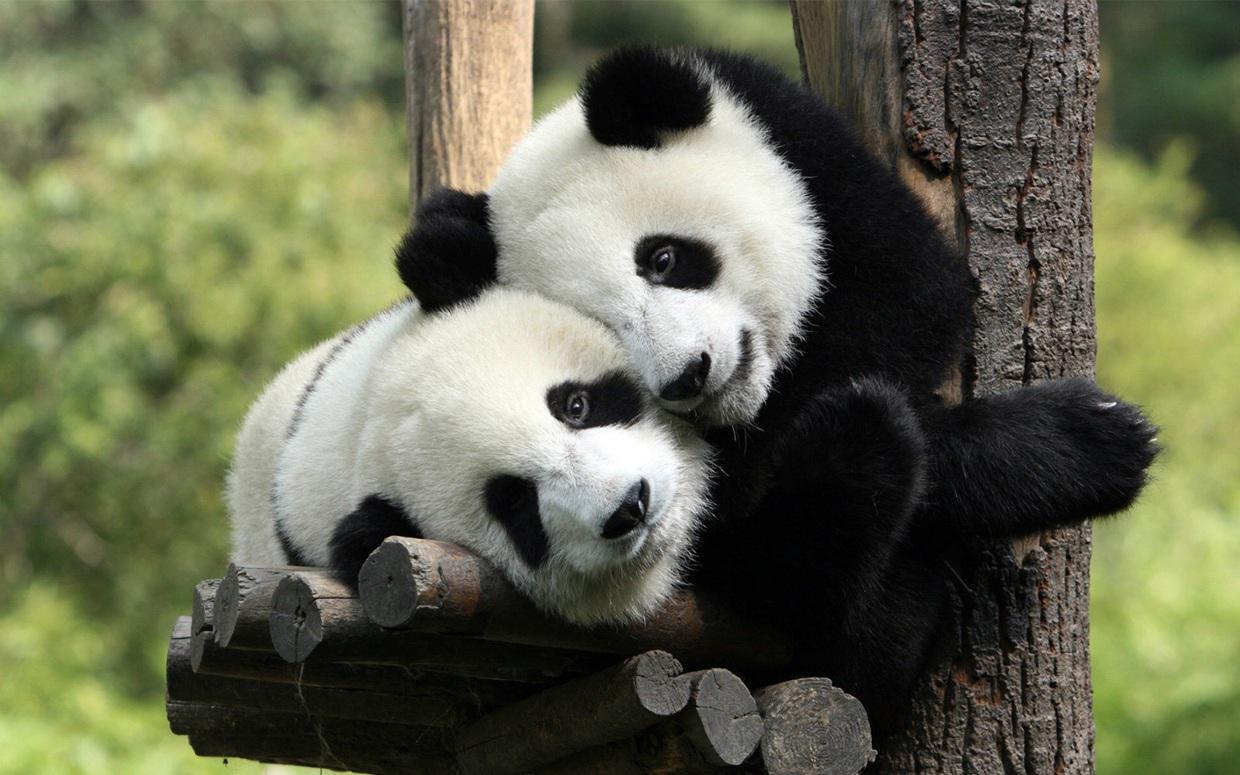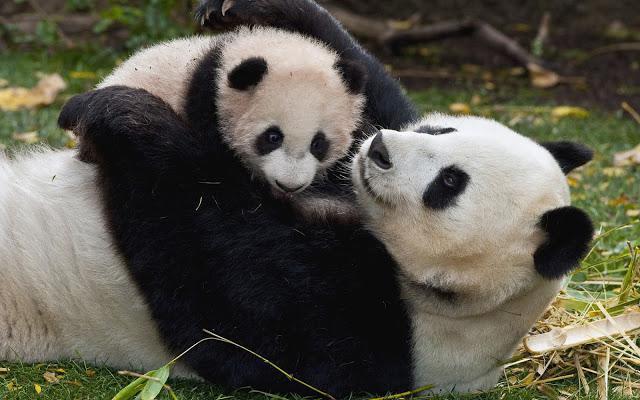The first image is the image on the left, the second image is the image on the right. Examine the images to the left and right. Is the description "The right image contains two pandas in close contact." accurate? Answer yes or no. Yes. The first image is the image on the left, the second image is the image on the right. Given the left and right images, does the statement "There is at least one pair of pandas hugging." hold true? Answer yes or no. Yes. 